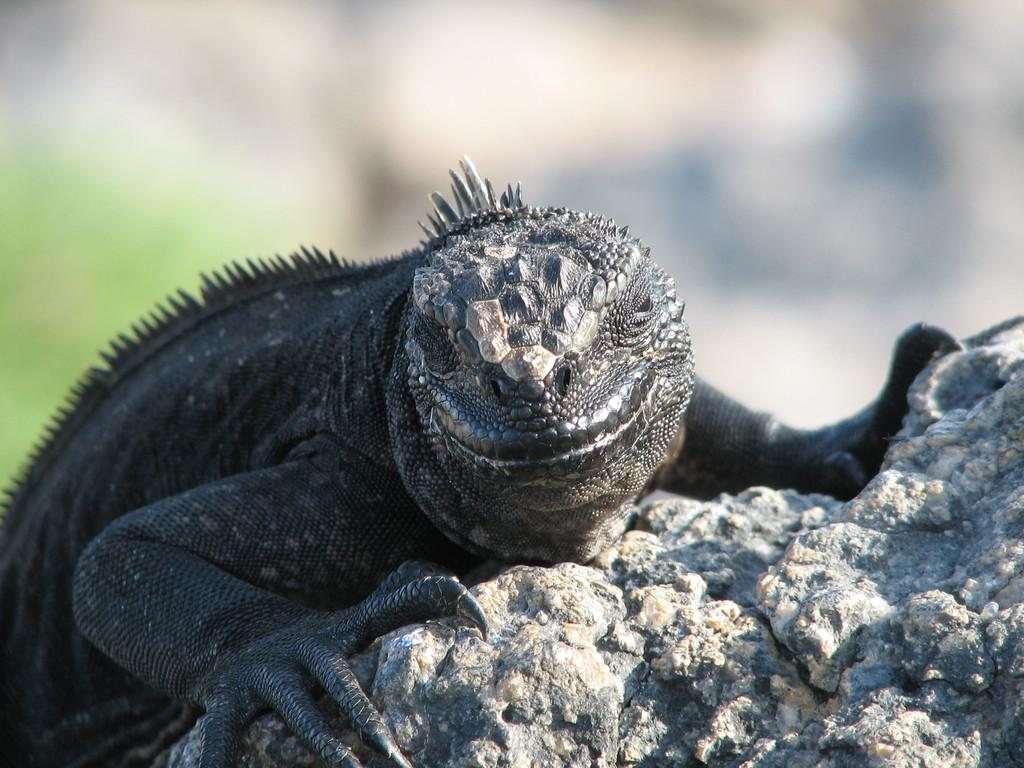What type of animal can be seen in the image? There is an animal in the image, but its specific type cannot be determined from the provided facts. What color is the animal in the image? The animal is black in color. Where is the animal located in the image? The animal is on a rock. What can be said about the background of the image? The background of the image is blurred. What type of work is the animal doing in the image? There is no indication in the image that the animal is doing any work, as animals do not typically engage in human-like activities. 